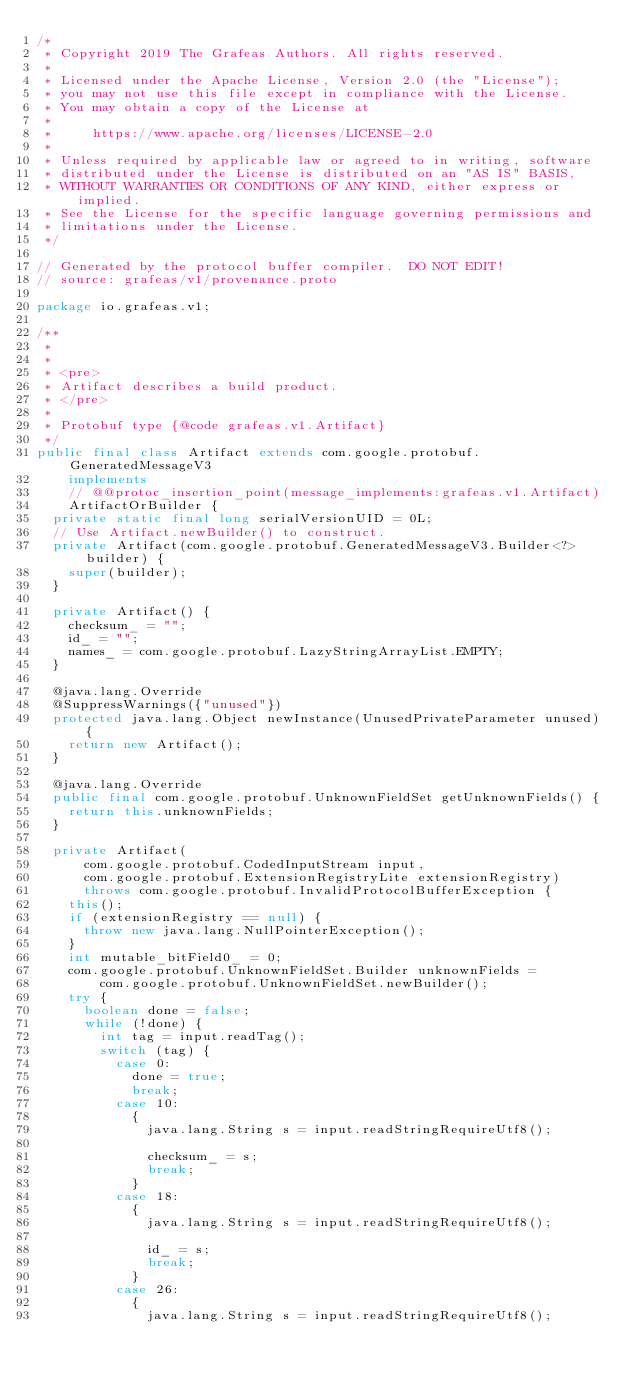<code> <loc_0><loc_0><loc_500><loc_500><_Java_>/*
 * Copyright 2019 The Grafeas Authors. All rights reserved.
 *
 * Licensed under the Apache License, Version 2.0 (the "License");
 * you may not use this file except in compliance with the License.
 * You may obtain a copy of the License at
 *
 *     https://www.apache.org/licenses/LICENSE-2.0
 *
 * Unless required by applicable law or agreed to in writing, software
 * distributed under the License is distributed on an "AS IS" BASIS,
 * WITHOUT WARRANTIES OR CONDITIONS OF ANY KIND, either express or implied.
 * See the License for the specific language governing permissions and
 * limitations under the License.
 */

// Generated by the protocol buffer compiler.  DO NOT EDIT!
// source: grafeas/v1/provenance.proto

package io.grafeas.v1;

/**
 *
 *
 * <pre>
 * Artifact describes a build product.
 * </pre>
 *
 * Protobuf type {@code grafeas.v1.Artifact}
 */
public final class Artifact extends com.google.protobuf.GeneratedMessageV3
    implements
    // @@protoc_insertion_point(message_implements:grafeas.v1.Artifact)
    ArtifactOrBuilder {
  private static final long serialVersionUID = 0L;
  // Use Artifact.newBuilder() to construct.
  private Artifact(com.google.protobuf.GeneratedMessageV3.Builder<?> builder) {
    super(builder);
  }

  private Artifact() {
    checksum_ = "";
    id_ = "";
    names_ = com.google.protobuf.LazyStringArrayList.EMPTY;
  }

  @java.lang.Override
  @SuppressWarnings({"unused"})
  protected java.lang.Object newInstance(UnusedPrivateParameter unused) {
    return new Artifact();
  }

  @java.lang.Override
  public final com.google.protobuf.UnknownFieldSet getUnknownFields() {
    return this.unknownFields;
  }

  private Artifact(
      com.google.protobuf.CodedInputStream input,
      com.google.protobuf.ExtensionRegistryLite extensionRegistry)
      throws com.google.protobuf.InvalidProtocolBufferException {
    this();
    if (extensionRegistry == null) {
      throw new java.lang.NullPointerException();
    }
    int mutable_bitField0_ = 0;
    com.google.protobuf.UnknownFieldSet.Builder unknownFields =
        com.google.protobuf.UnknownFieldSet.newBuilder();
    try {
      boolean done = false;
      while (!done) {
        int tag = input.readTag();
        switch (tag) {
          case 0:
            done = true;
            break;
          case 10:
            {
              java.lang.String s = input.readStringRequireUtf8();

              checksum_ = s;
              break;
            }
          case 18:
            {
              java.lang.String s = input.readStringRequireUtf8();

              id_ = s;
              break;
            }
          case 26:
            {
              java.lang.String s = input.readStringRequireUtf8();</code> 